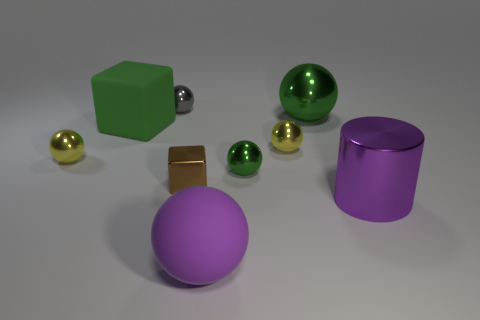Does the big matte block have the same color as the big cylinder?
Your answer should be very brief. No. There is a big metallic thing behind the small brown cube; does it have the same shape as the small yellow shiny object on the right side of the green rubber object?
Offer a terse response. Yes. There is a tiny gray ball to the left of the rubber thing in front of the large cube; how many small spheres are left of it?
Your answer should be compact. 1. What material is the green thing that is left of the tiny thing that is behind the large shiny sphere on the left side of the purple cylinder?
Make the answer very short. Rubber. Do the big ball that is on the right side of the big matte sphere and the brown thing have the same material?
Make the answer very short. Yes. What number of metal cylinders are the same size as the green rubber cube?
Your response must be concise. 1. Are there more gray spheres that are in front of the small gray thing than metallic blocks left of the big metallic cylinder?
Ensure brevity in your answer.  No. Is there a large green metallic object of the same shape as the purple metallic thing?
Offer a very short reply. No. There is a cube behind the yellow metal object that is on the left side of the tiny gray ball; what is its size?
Offer a terse response. Large. There is a tiny metal object behind the small yellow metal ball on the right side of the thing in front of the shiny cylinder; what shape is it?
Keep it short and to the point. Sphere. 